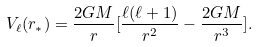Convert formula to latex. <formula><loc_0><loc_0><loc_500><loc_500>V _ { \ell } ( r _ { * } ) = \frac { 2 G M } { r } [ \frac { \ell ( \ell + 1 ) } { r ^ { 2 } } - \frac { 2 G M } { r ^ { 3 } } ] .</formula> 